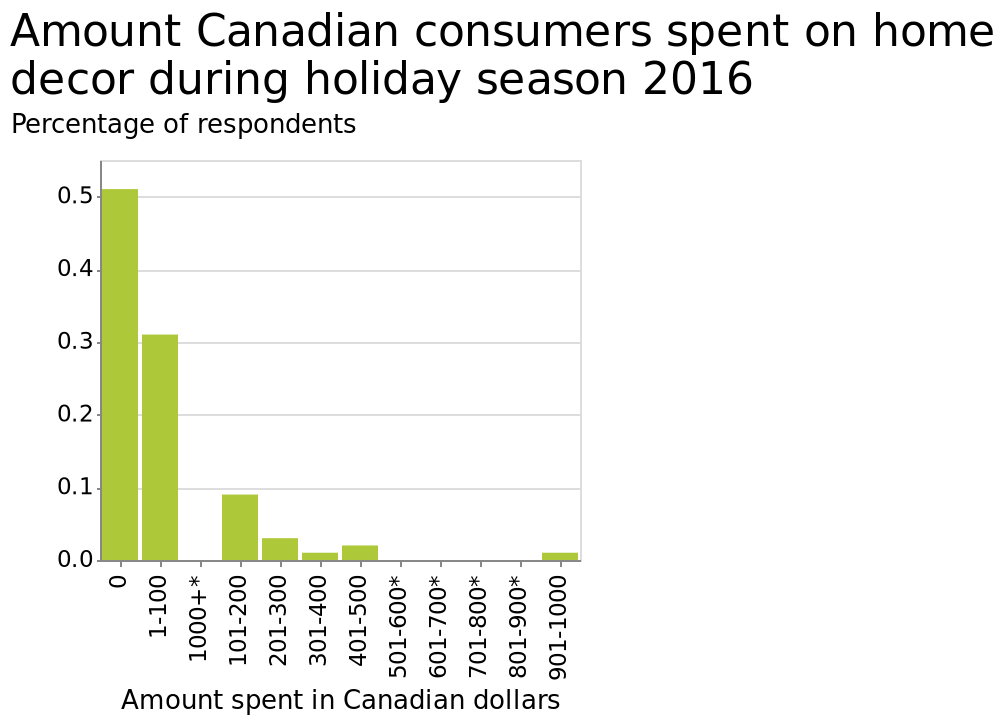<image>
Were there any Canadians who did not engage in decor activities during spring 2016? Yes, according to the chart, the vast majority of Canadians did not do any decor over spring 2016. What was the level of participation in decor activities among Canadians in spring 2016? The chart suggests that the level of participation in decor activities among Canadians in spring 2016 was low, as the majority did not do any decor. What does the y-axis represent? The y-axis represents the percentage of respondents. 